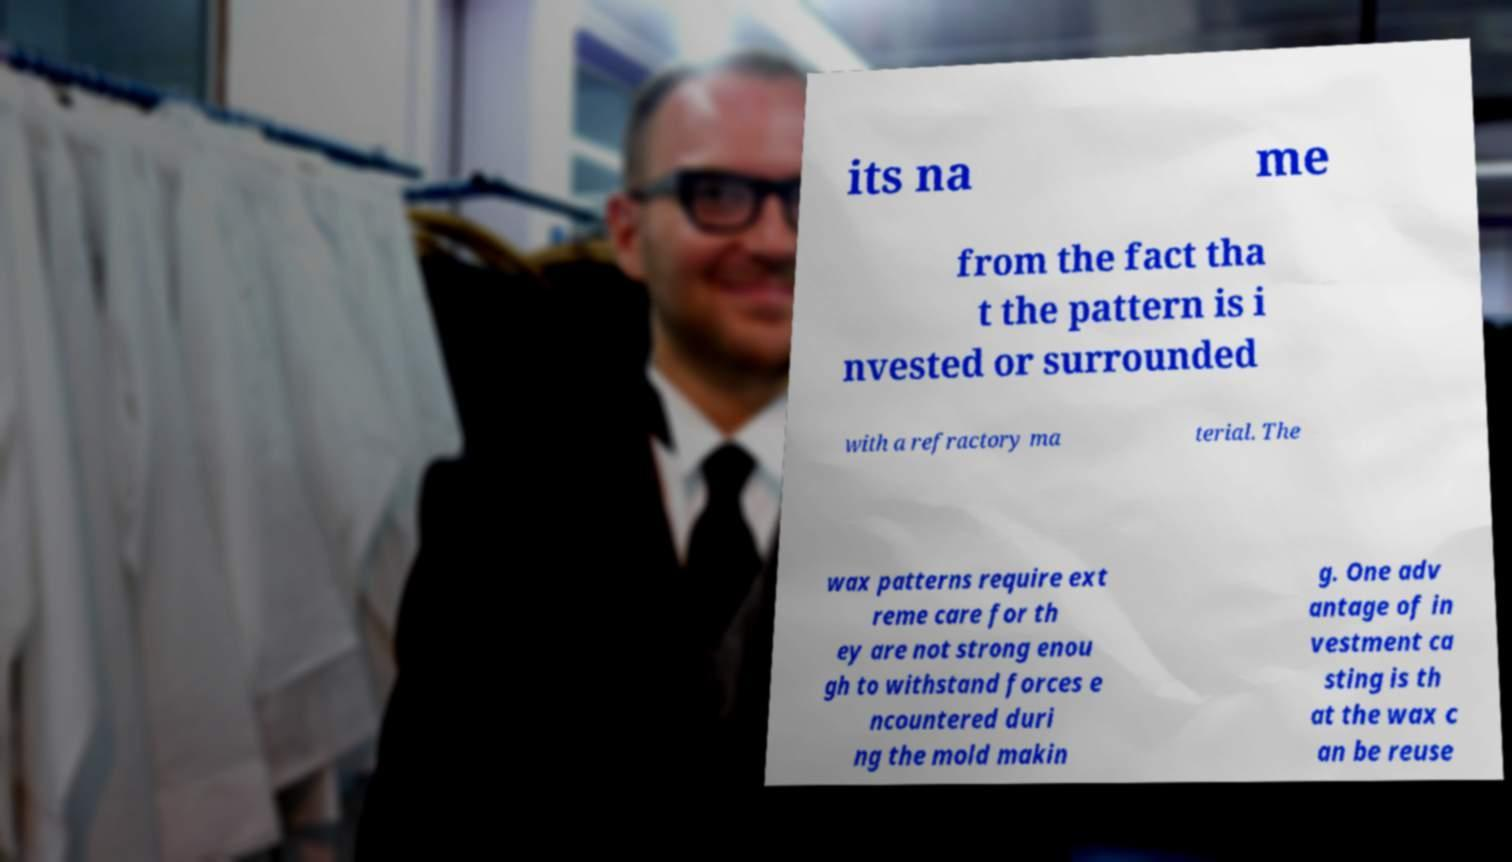Please read and relay the text visible in this image. What does it say? its na me from the fact tha t the pattern is i nvested or surrounded with a refractory ma terial. The wax patterns require ext reme care for th ey are not strong enou gh to withstand forces e ncountered duri ng the mold makin g. One adv antage of in vestment ca sting is th at the wax c an be reuse 